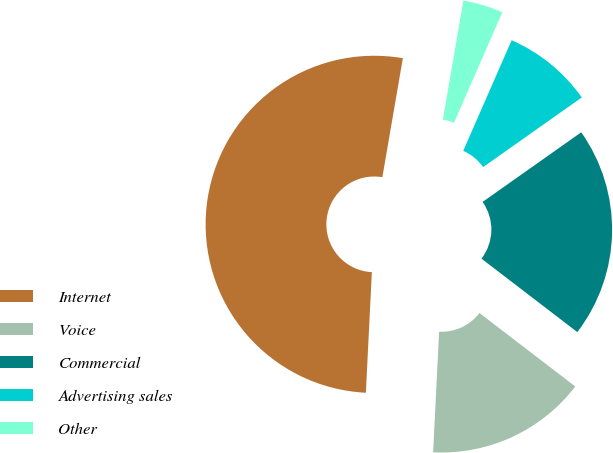Convert chart. <chart><loc_0><loc_0><loc_500><loc_500><pie_chart><fcel>Internet<fcel>Voice<fcel>Commercial<fcel>Advertising sales<fcel>Other<nl><fcel>51.92%<fcel>15.38%<fcel>20.19%<fcel>8.65%<fcel>3.85%<nl></chart> 